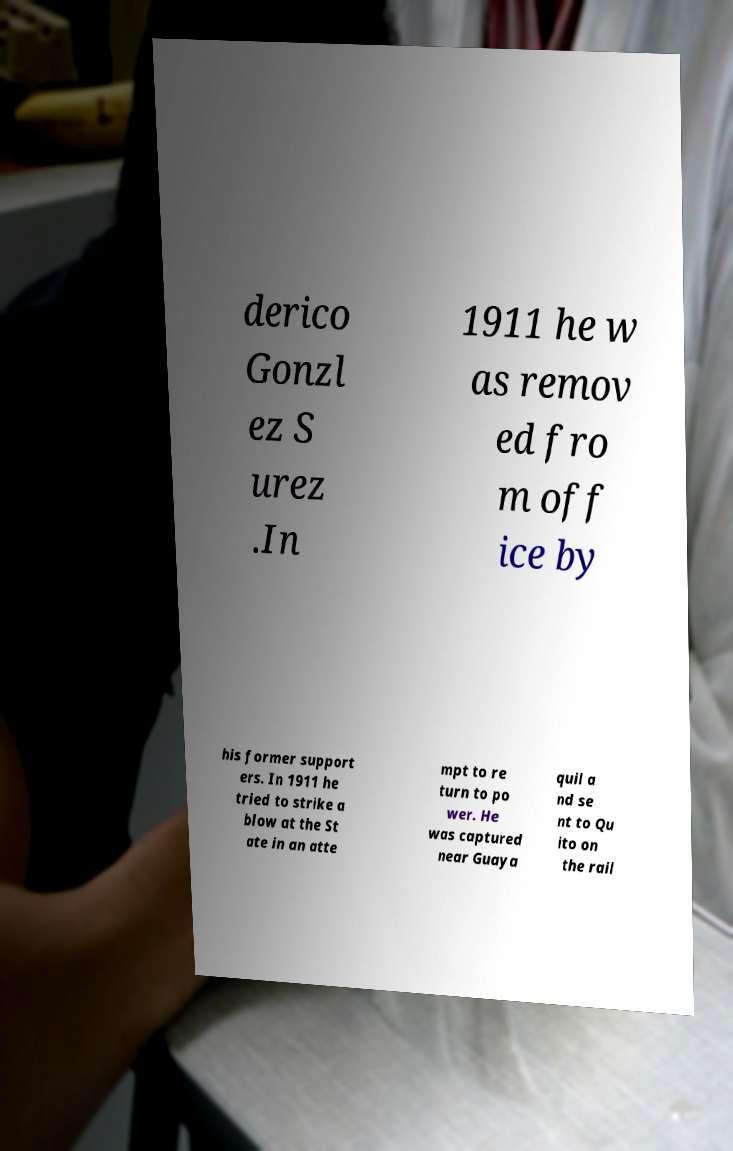Can you read and provide the text displayed in the image?This photo seems to have some interesting text. Can you extract and type it out for me? derico Gonzl ez S urez .In 1911 he w as remov ed fro m off ice by his former support ers. In 1911 he tried to strike a blow at the St ate in an atte mpt to re turn to po wer. He was captured near Guaya quil a nd se nt to Qu ito on the rail 